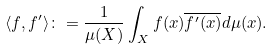Convert formula to latex. <formula><loc_0><loc_0><loc_500><loc_500>\langle f , f ^ { \prime } \rangle \colon = \frac { 1 } { \mu ( X ) } \int _ { X } f ( x ) \overline { f ^ { \prime } ( x ) } d \mu ( x ) .</formula> 